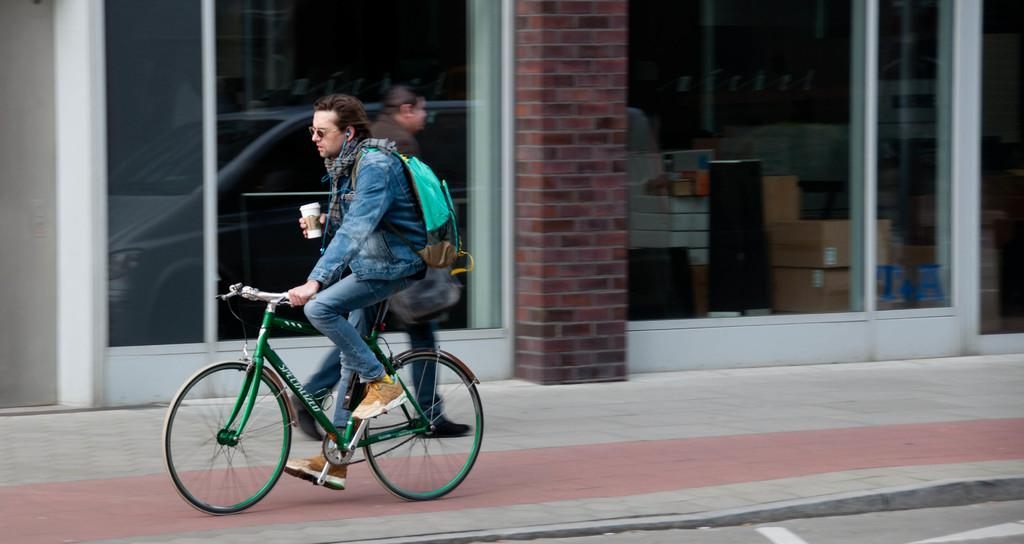What is the man in the image doing? The man in the image is cycling. Is the man carrying anything while cycling? Yes, the man is carrying a bag. Can you describe the scene in the background of the image? There is another person visible in the background of the image. What type of bait is the man using while cycling in the image? There is no mention of bait or fishing in the image; the man is cycling and carrying a bag. Is the man holding an umbrella while cycling in the image? There is no umbrella present in the image; the man is cycling and carrying a bag. 